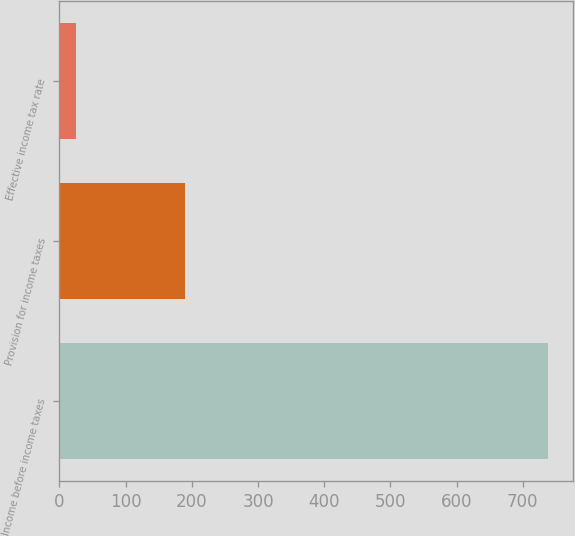Convert chart. <chart><loc_0><loc_0><loc_500><loc_500><bar_chart><fcel>Income before income taxes<fcel>Provision for income taxes<fcel>Effective income tax rate<nl><fcel>738.4<fcel>190.2<fcel>25.8<nl></chart> 